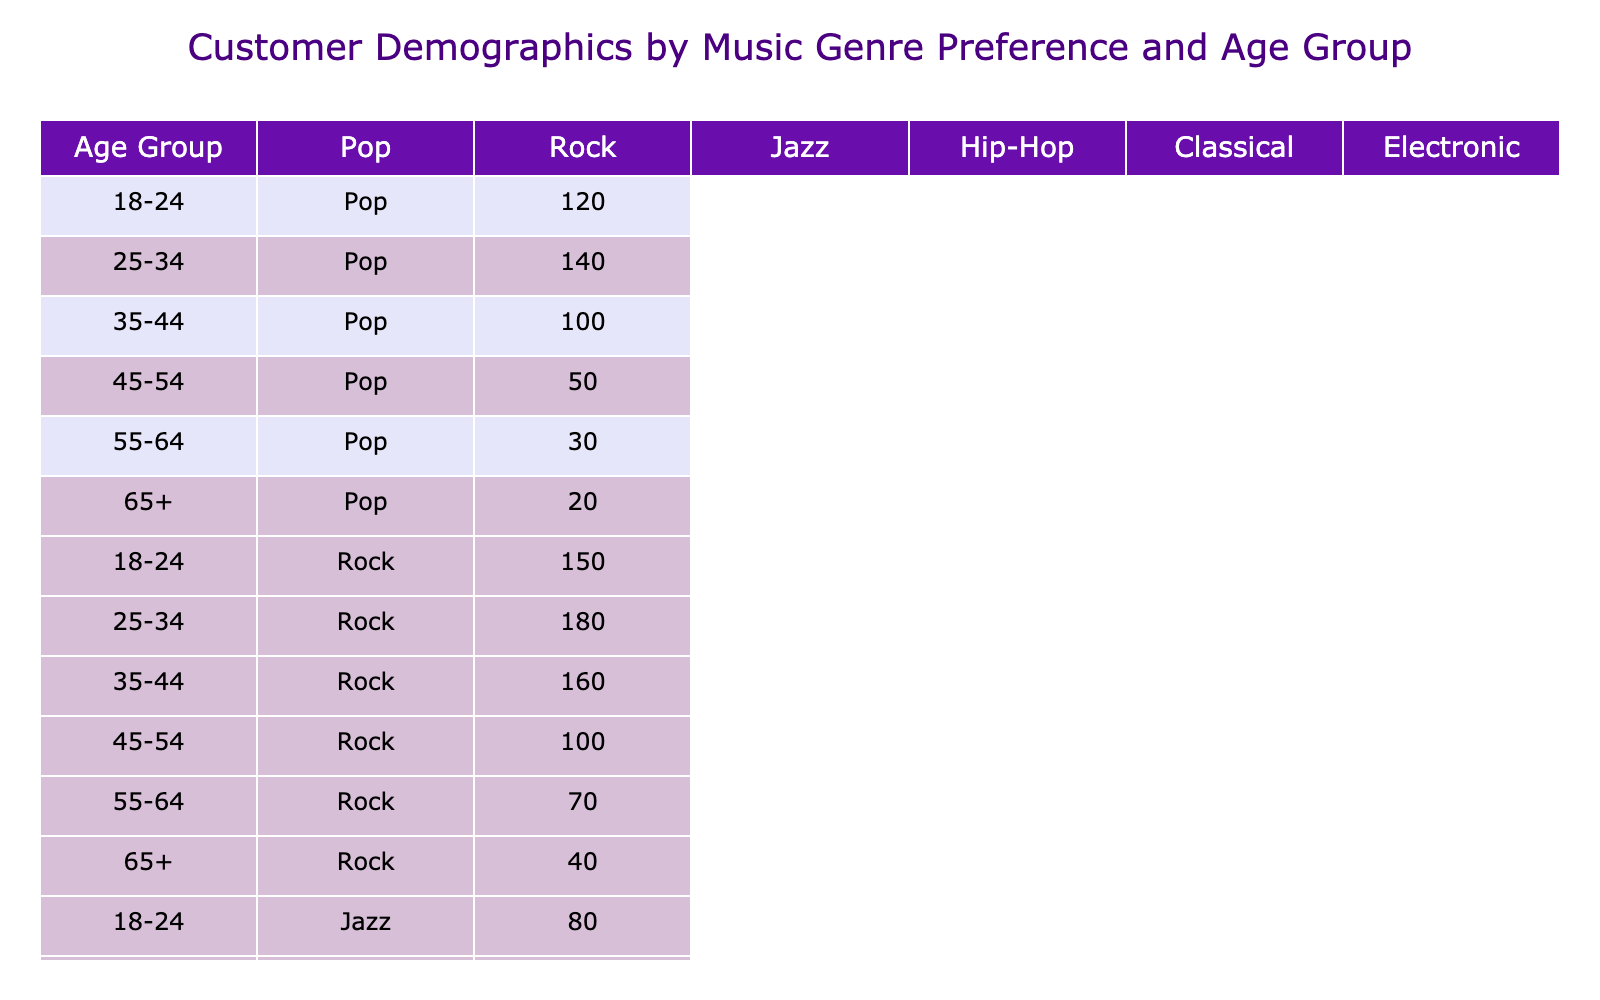What age group has the highest preference for Hip-Hop music? By looking at the Hip-Hop column, the counts for each age group are: 200 for 18-24, 220 for 25-34, 150 for 35-44, 80 for 45-54, 40 for 55-64, and 30 for 65+. The highest count is 220 for the 25-34 age group.
Answer: 25-34 Which music genre is favored the least by the 45-54 age group? In the 45-54 age group, the counts for each genre are: Pop (50), Rock (100), Jazz (90), Hip-Hop (80), Classical (60), and Electronic (50). The least count is 50 for both Pop and Electronic genres, but since we are looking for only one, we can state that Electronic is also tied.
Answer: Pop and Electronic What is the total number of customers in the 35-44 age group who prefer Classical music? The count for the Classical music genre in the 35-44 age group is 50. There are no additional calculations since we are only required to provide the number for this specific genre and age group.
Answer: 50 Is there a higher preference for Jazz music in the 55-64 age group compared to the 65+ age group? The count for Jazz in the 55-64 age group is 110 and for 65+ it is 60. Since 110 is greater than 60, the preference for Jazz in the 55-64 age group is indeed higher.
Answer: Yes What is the average preference for Electronic music across all age groups? The counts for Electronic music across age groups are: 90 (18-24), 100 (25-34), 80 (35-44), 50 (45-54), 30 (55-64), and 10 (65+). First, we sum these values: 90 + 100 + 80 + 50 + 30 + 10 = 360. Then we find the average by dividing by the number of age groups, which is 6. So, the average is 360 / 6 = 60.
Answer: 60 What genre has the highest overall preference in the age group 18-24? Looking at the 18-24 age group counts: Pop (120), Rock (150), Jazz (80), Hip-Hop (200), Classical (30), and Electronic (90). The highest count is for Hip-Hop at 200, as it is more than all other genres in this age group.
Answer: Hip-Hop 